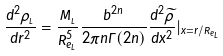<formula> <loc_0><loc_0><loc_500><loc_500>\frac { d ^ { 2 } \rho _ { _ { L } } } { d r ^ { 2 } } = \frac { { M } _ { _ { L } } } { R _ { e _ { L } } ^ { 5 } } \frac { b ^ { 2 n } } { 2 \pi n \Gamma ( 2 n ) } \frac { d ^ { 2 } \widetilde { \rho } } { d x ^ { 2 } } | _ { x = r / R _ { e _ { L } } }</formula> 